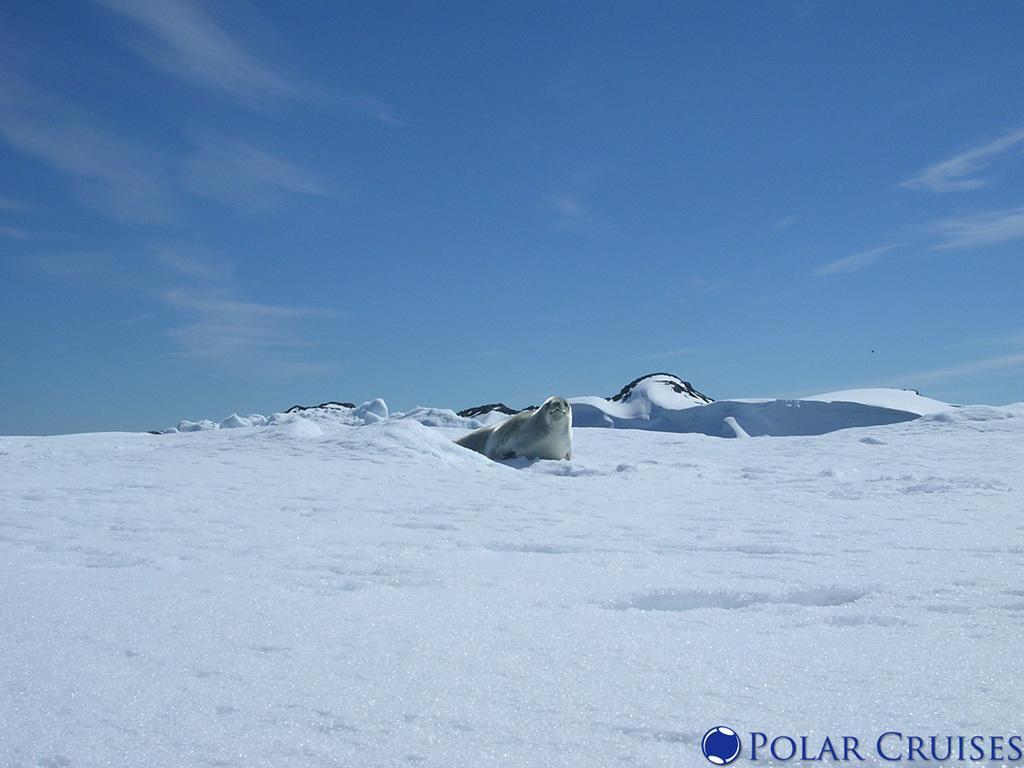Describe this image in one or two sentences. In this picture I can see the polar animal. I can see snow. I can see clouds in the sky. 